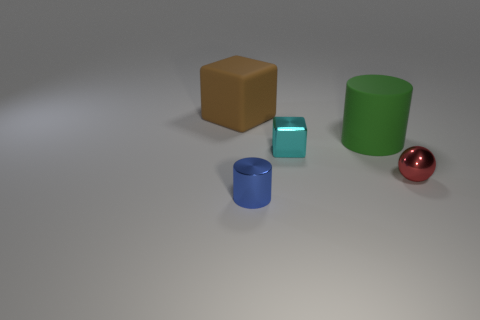What material is the blue object?
Your answer should be very brief. Metal. What is the size of the green object that is the same shape as the small blue metallic object?
Your response must be concise. Large. How many other objects are the same material as the blue thing?
Offer a terse response. 2. Are there an equal number of things in front of the small cyan cube and tiny gray metal cylinders?
Your answer should be compact. No. There is a cube behind the green matte cylinder; does it have the same size as the green thing?
Your answer should be very brief. Yes. How many things are to the left of the tiny cube?
Your answer should be very brief. 2. There is a object that is both on the right side of the cyan metal thing and to the left of the metallic sphere; what material is it?
Offer a very short reply. Rubber. What number of big things are blocks or green things?
Your answer should be very brief. 2. What size is the brown rubber thing?
Your answer should be compact. Large. The cyan thing has what shape?
Keep it short and to the point. Cube. 